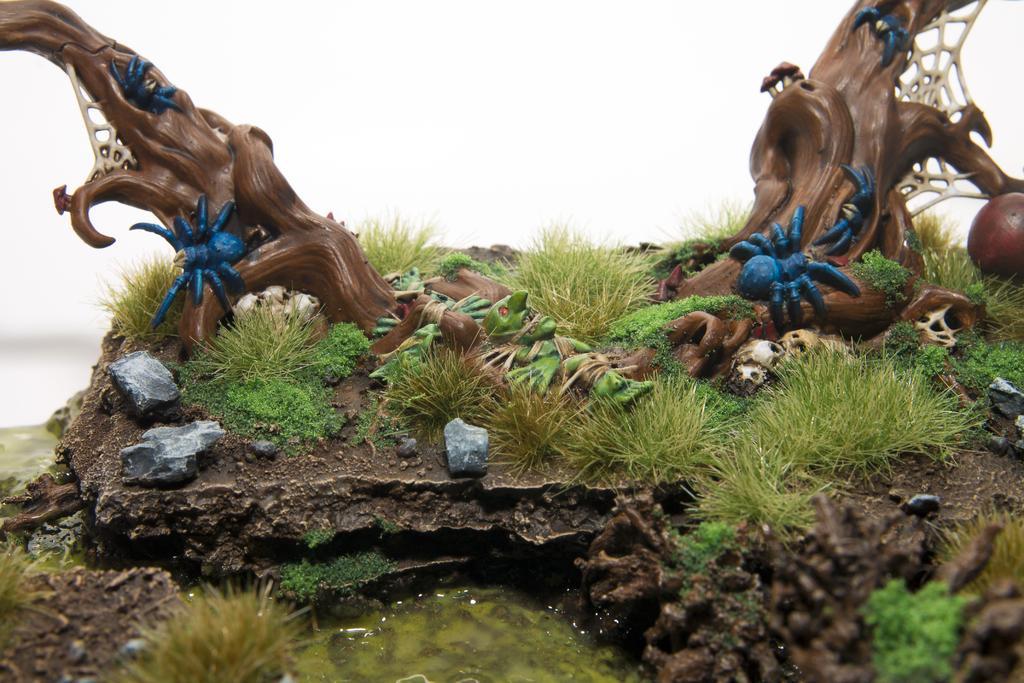Please provide a concise description of this image. We can see sculptures of tree branches and insects. We can see grass,water and stones. In the background it is white. 